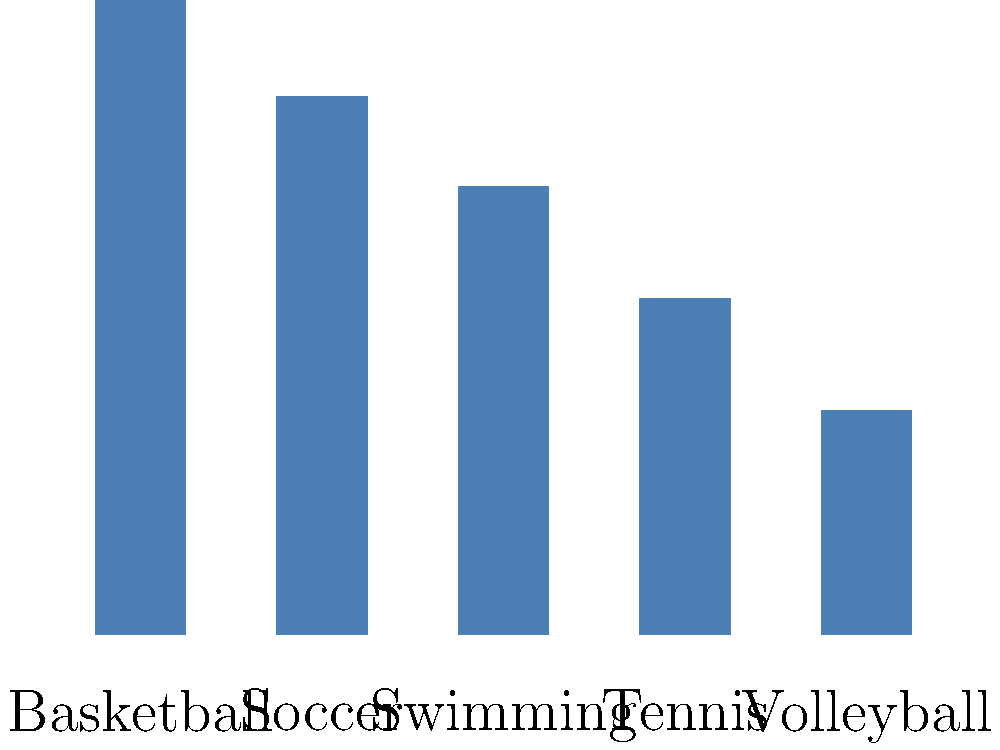Based on the bar graph showing the popularity of different sports programs, which two programs should be prioritized for expansion to maximize participation and potential revenue? To determine which two programs should be prioritized, we need to analyze the popularity percentages of each sport:

1. Basketball: 85%
2. Soccer: 72%
3. Swimming: 60%
4. Tennis: 45%
5. Volleyball: 30%

Step 1: Identify the most popular program
Basketball has the highest popularity at 85%.

Step 2: Identify the second most popular program
Soccer is the second most popular at 72%.

Step 3: Consider the gap between the top two and the rest
There is a significant gap between Soccer (72%) and Swimming (60%), the third most popular sport.

Step 4: Evaluate potential for growth and revenue
The two most popular sports, Basketball and Soccer, have the highest participation rates, which suggests they have the greatest potential for expansion, increased participation, and revenue generation.

Step 5: Make a decision based on the data
Prioritizing Basketball and Soccer for expansion would likely yield the best results in terms of maximizing participation and potential revenue due to their already high popularity.
Answer: Basketball and Soccer 